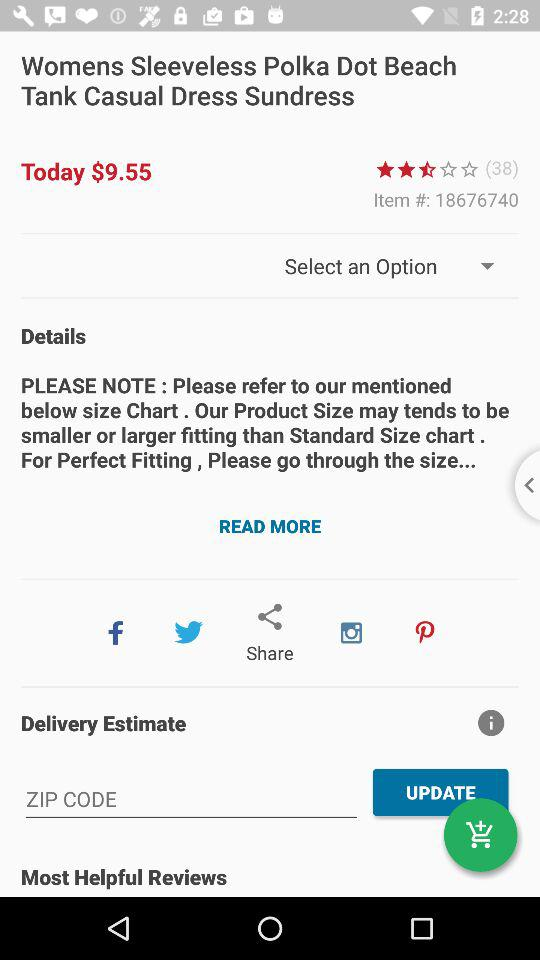How many people rated the product? There are 38 people who rated the product. 